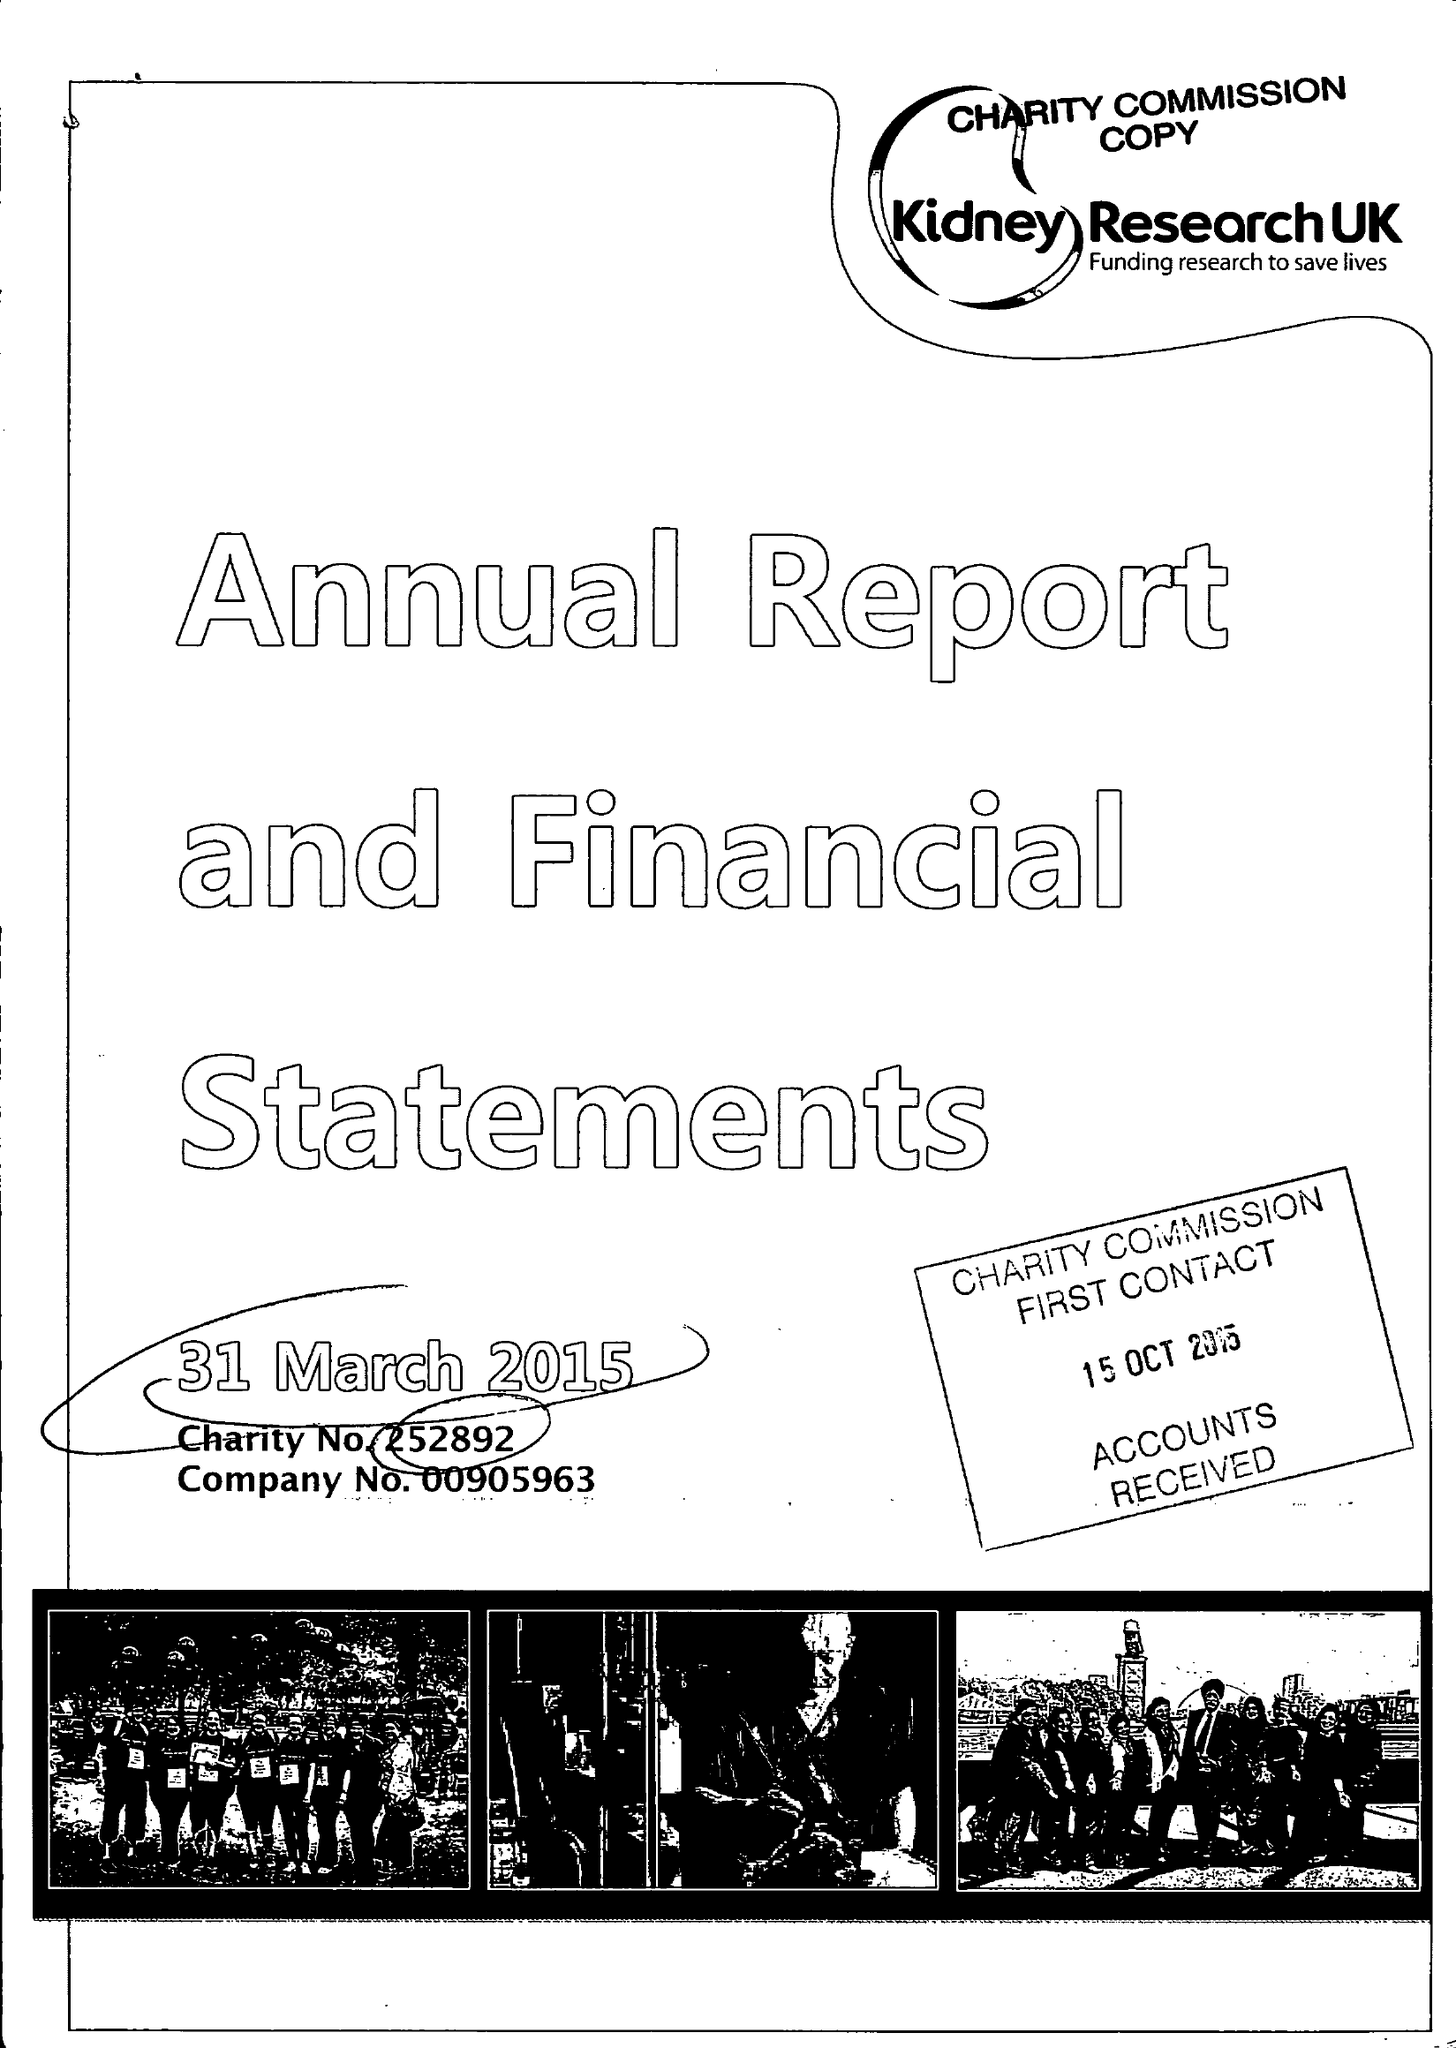What is the value for the address__street_line?
Answer the question using a single word or phrase. None 